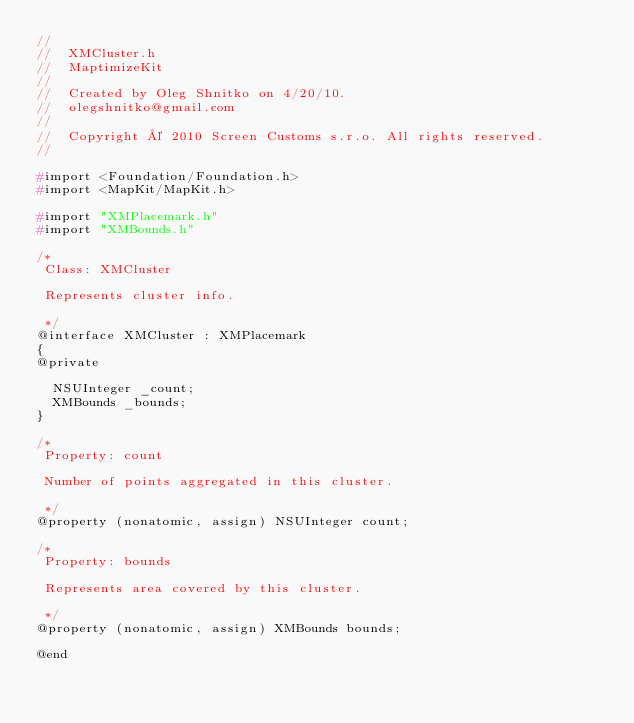<code> <loc_0><loc_0><loc_500><loc_500><_C_>//
//  XMCluster.h
//  MaptimizeKit
//
//  Created by Oleg Shnitko on 4/20/10.
//  olegshnitko@gmail.com
//  
//  Copyright © 2010 Screen Customs s.r.o. All rights reserved.
//

#import <Foundation/Foundation.h>
#import <MapKit/MapKit.h>

#import "XMPlacemark.h"
#import "XMBounds.h"

/*
 Class: XMCluster
 
 Represents cluster info.
 
 */
@interface XMCluster : XMPlacemark
{
@private

	NSUInteger _count;
	XMBounds _bounds;
}

/*
 Property: count
 
 Number of points aggregated in this cluster.
 
 */
@property (nonatomic, assign) NSUInteger count;

/*
 Property: bounds
 
 Represents area covered by this cluster.
 
 */
@property (nonatomic, assign) XMBounds bounds;

@end
</code> 